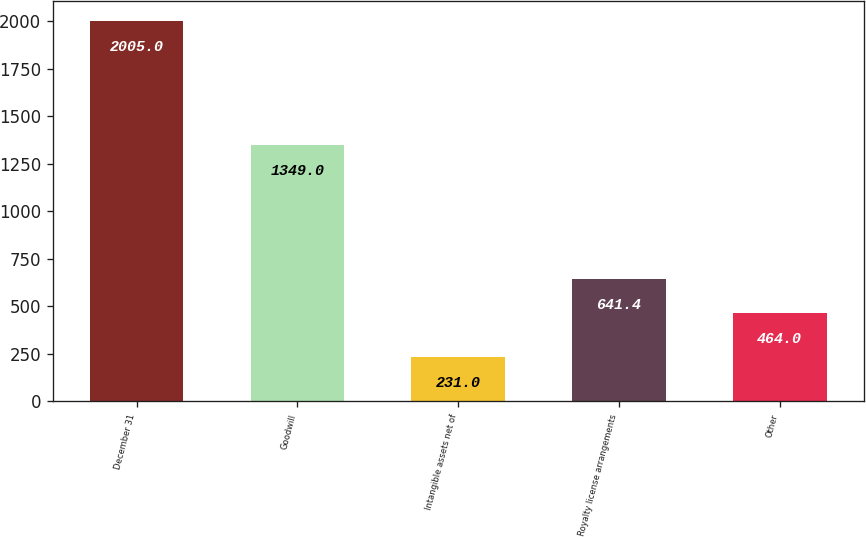Convert chart. <chart><loc_0><loc_0><loc_500><loc_500><bar_chart><fcel>December 31<fcel>Goodwill<fcel>Intangible assets net of<fcel>Royalty license arrangements<fcel>Other<nl><fcel>2005<fcel>1349<fcel>231<fcel>641.4<fcel>464<nl></chart> 